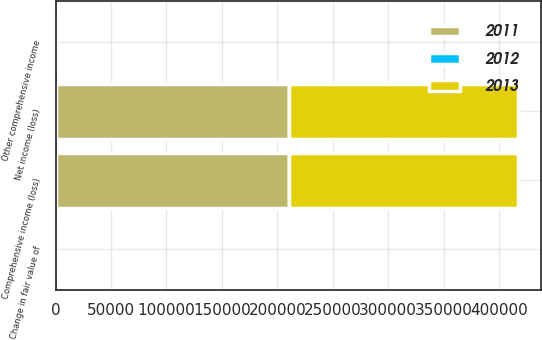<chart> <loc_0><loc_0><loc_500><loc_500><stacked_bar_chart><ecel><fcel>Net income (loss)<fcel>Change in fair value of<fcel>Other comprehensive income<fcel>Comprehensive income (loss)<nl><fcel>2012<fcel>314<fcel>197<fcel>197<fcel>314<nl><fcel>2013<fcel>206145<fcel>314<fcel>314<fcel>206459<nl><fcel>2011<fcel>210388<fcel>213<fcel>213<fcel>210175<nl></chart> 